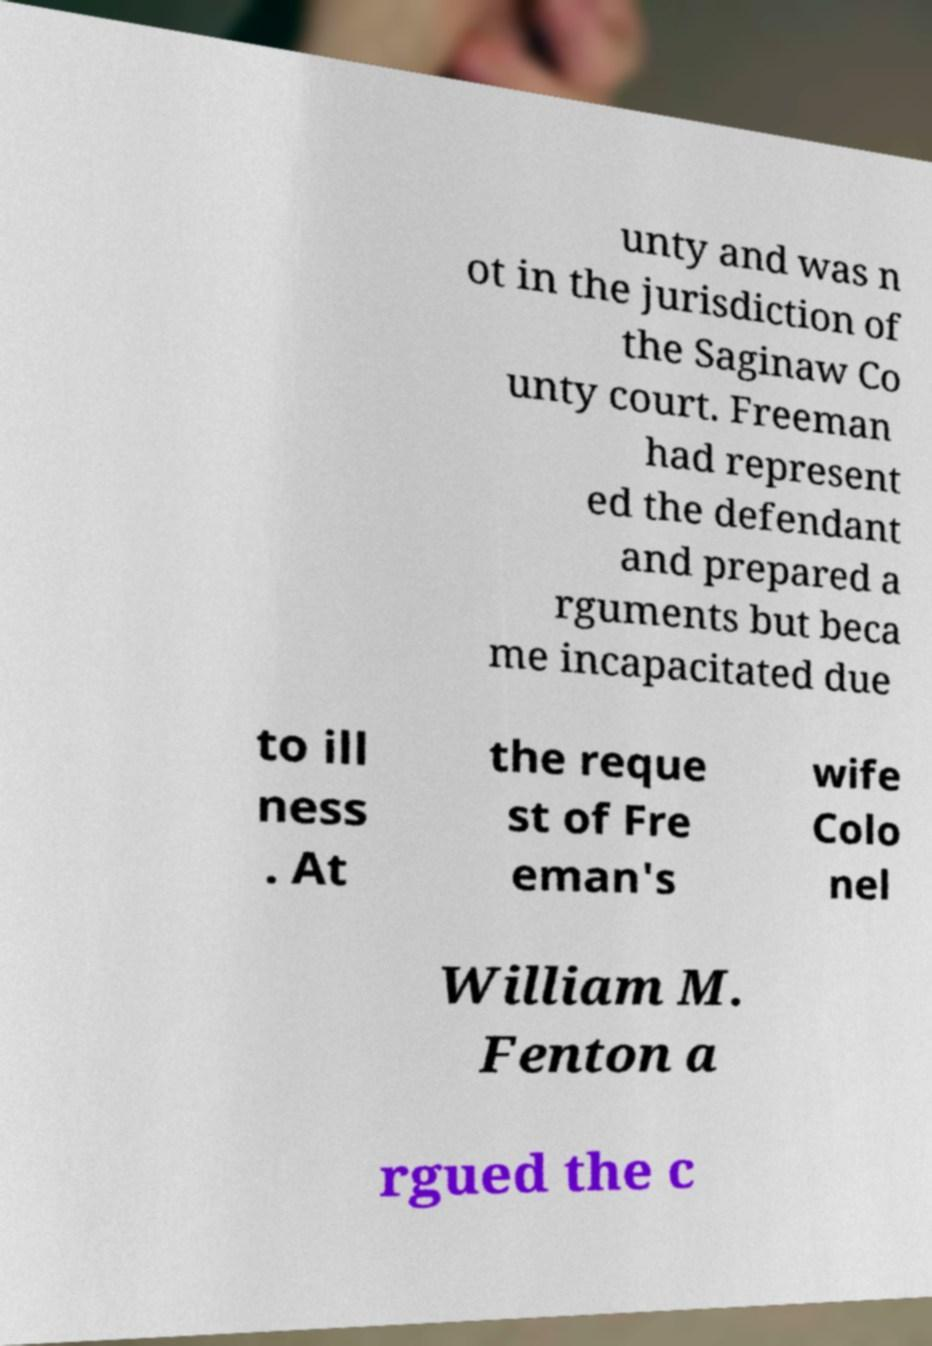Please read and relay the text visible in this image. What does it say? unty and was n ot in the jurisdiction of the Saginaw Co unty court. Freeman had represent ed the defendant and prepared a rguments but beca me incapacitated due to ill ness . At the reque st of Fre eman's wife Colo nel William M. Fenton a rgued the c 